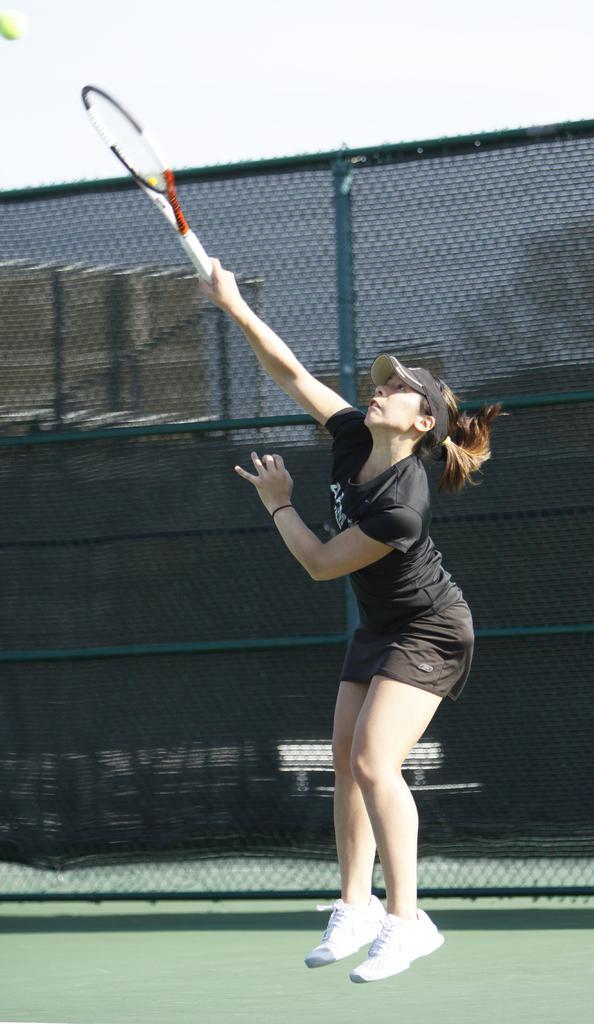Could you give a brief overview of what you see in this image? This is a picture of a women, who is in black dress and the women wearing a white shoes and the women is holding a tennis racket. On the air there is a ball which is in yellow color. Background of this woman is a fencing. 